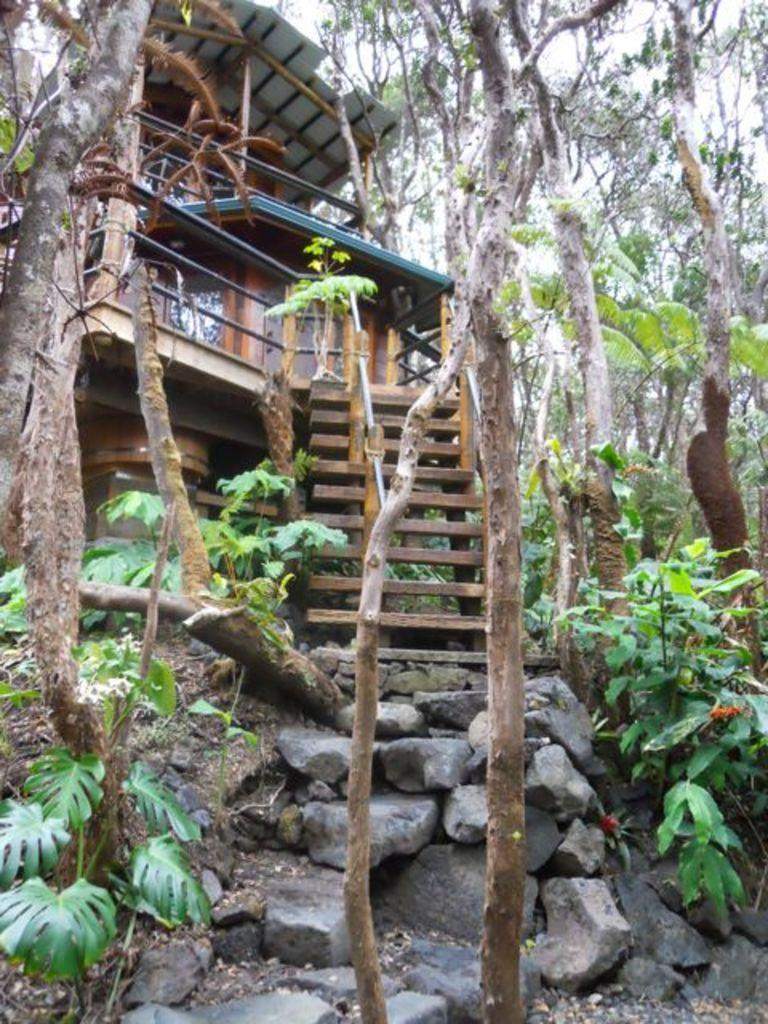What type of vegetation can be seen in the image? There are plants and trees in the image. What other objects or features are present in the image? There are rocks and a house in the image. What can be seen in the background of the image? The sky is visible in the background of the image. What type of pollution can be seen in the image? There is no pollution visible in the image. Can you describe the earth in the image? The image does not show the earth as a whole; it only depicts a portion of the landscape with plants, trees, rocks, a house, and the sky. 